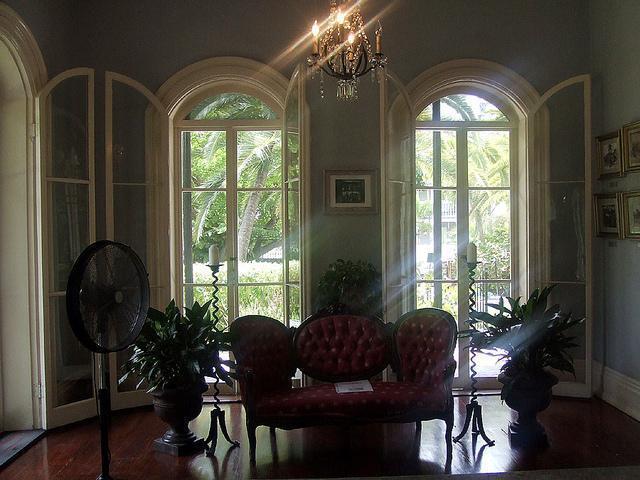How many potted plants do you see?
Give a very brief answer. 3. How many chairs are there?
Give a very brief answer. 1. How many potted plants are there?
Give a very brief answer. 3. How many chairs can be seen?
Give a very brief answer. 2. How many bowls are there in a row?
Give a very brief answer. 0. 